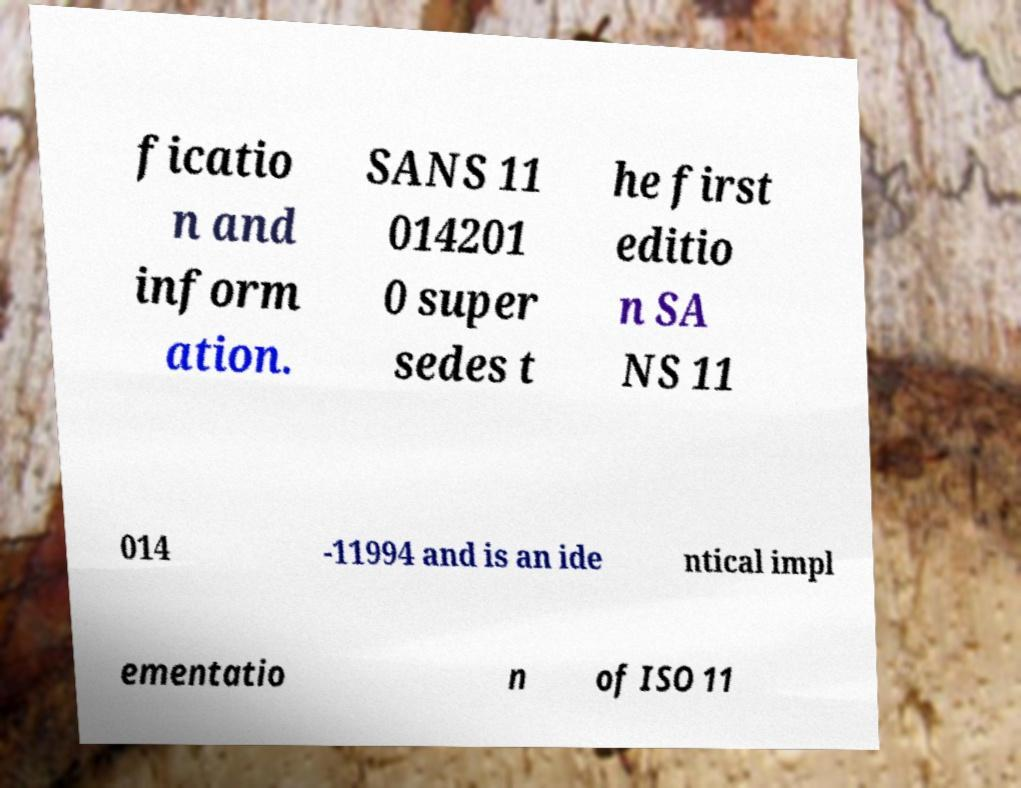Can you accurately transcribe the text from the provided image for me? ficatio n and inform ation. SANS 11 014201 0 super sedes t he first editio n SA NS 11 014 -11994 and is an ide ntical impl ementatio n of ISO 11 